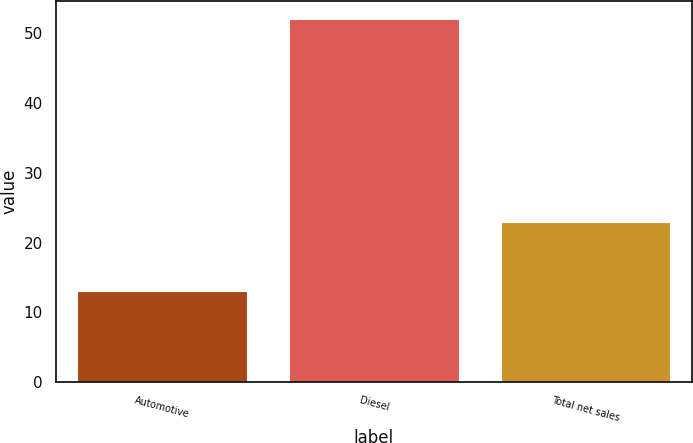Convert chart to OTSL. <chart><loc_0><loc_0><loc_500><loc_500><bar_chart><fcel>Automotive<fcel>Diesel<fcel>Total net sales<nl><fcel>13<fcel>52<fcel>23<nl></chart> 